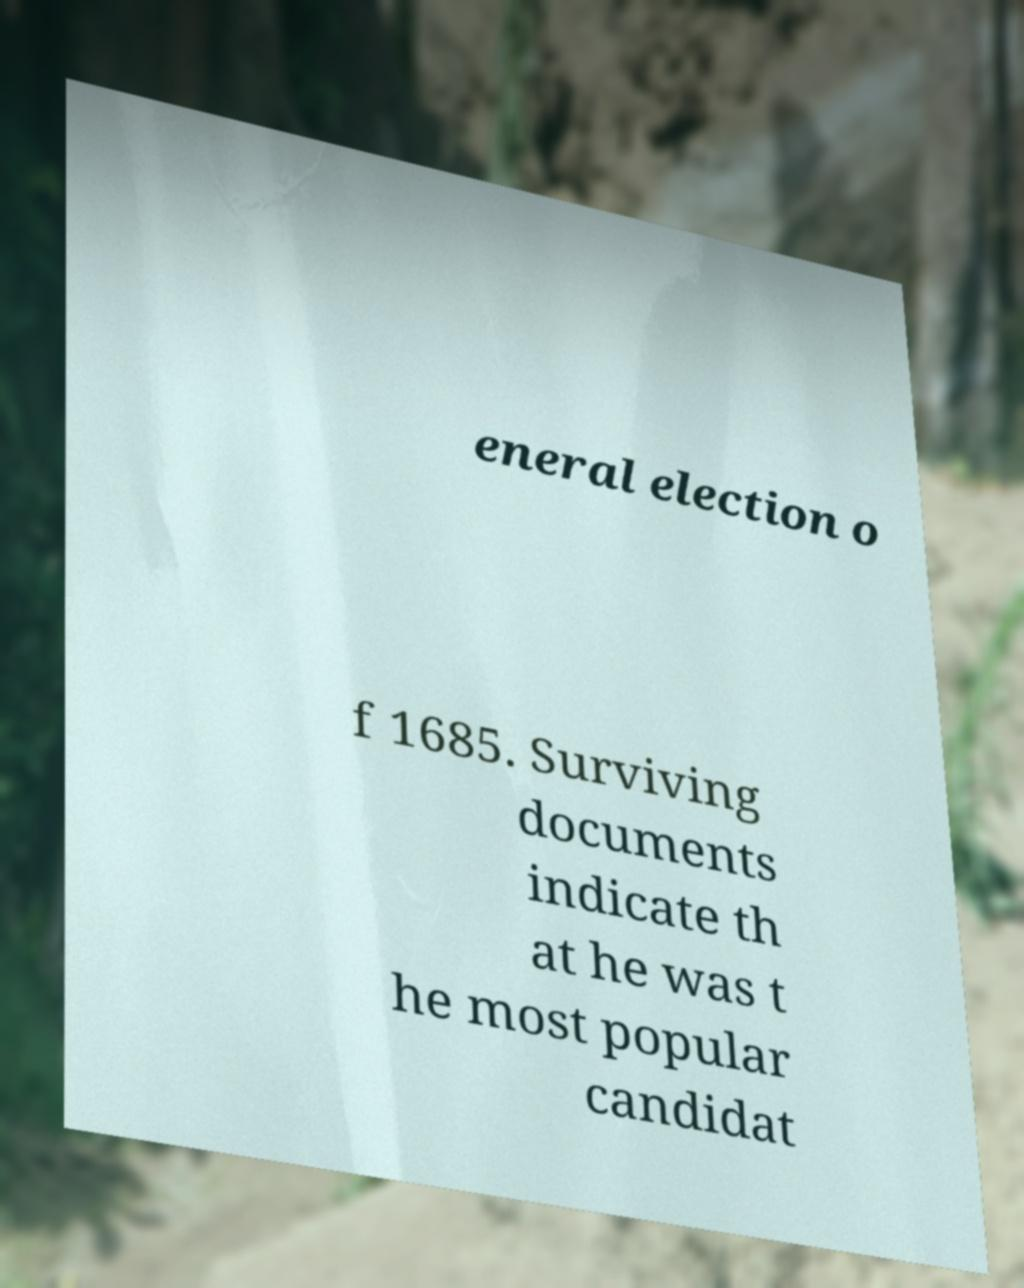Could you extract and type out the text from this image? eneral election o f 1685. Surviving documents indicate th at he was t he most popular candidat 